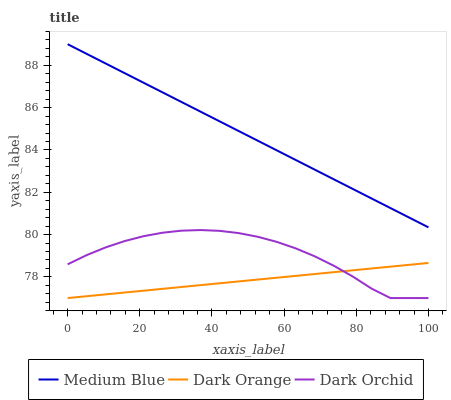Does Dark Orange have the minimum area under the curve?
Answer yes or no. Yes. Does Medium Blue have the maximum area under the curve?
Answer yes or no. Yes. Does Dark Orchid have the minimum area under the curve?
Answer yes or no. No. Does Dark Orchid have the maximum area under the curve?
Answer yes or no. No. Is Medium Blue the smoothest?
Answer yes or no. Yes. Is Dark Orchid the roughest?
Answer yes or no. Yes. Is Dark Orchid the smoothest?
Answer yes or no. No. Is Medium Blue the roughest?
Answer yes or no. No. Does Medium Blue have the lowest value?
Answer yes or no. No. Does Dark Orchid have the highest value?
Answer yes or no. No. Is Dark Orchid less than Medium Blue?
Answer yes or no. Yes. Is Medium Blue greater than Dark Orange?
Answer yes or no. Yes. Does Dark Orchid intersect Medium Blue?
Answer yes or no. No. 